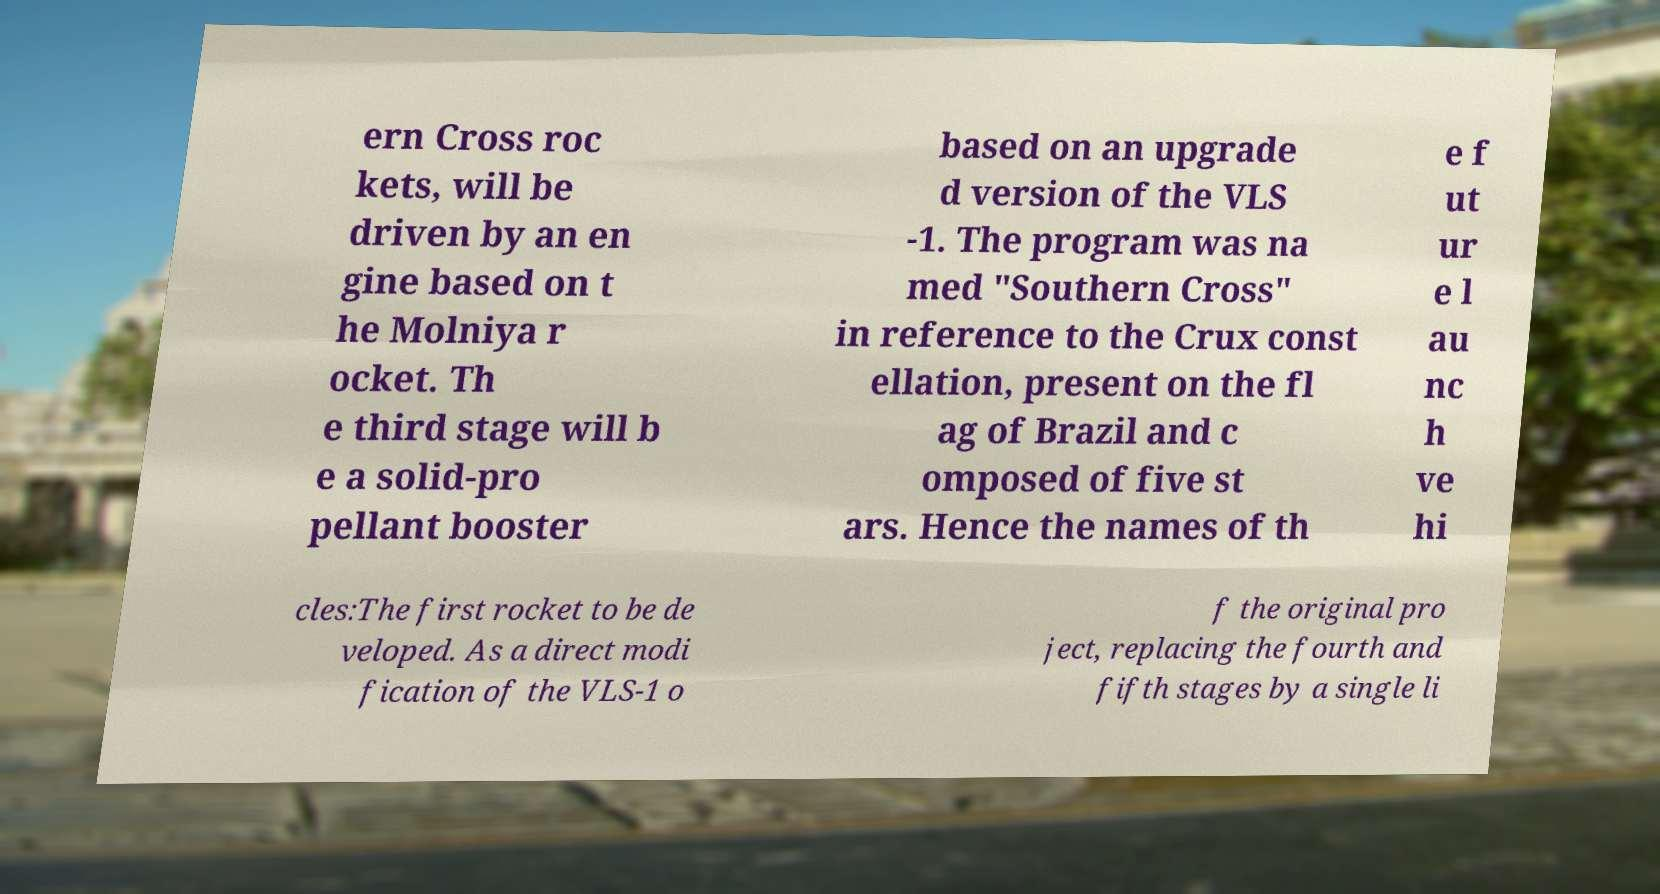Can you read and provide the text displayed in the image?This photo seems to have some interesting text. Can you extract and type it out for me? ern Cross roc kets, will be driven by an en gine based on t he Molniya r ocket. Th e third stage will b e a solid-pro pellant booster based on an upgrade d version of the VLS -1. The program was na med "Southern Cross" in reference to the Crux const ellation, present on the fl ag of Brazil and c omposed of five st ars. Hence the names of th e f ut ur e l au nc h ve hi cles:The first rocket to be de veloped. As a direct modi fication of the VLS-1 o f the original pro ject, replacing the fourth and fifth stages by a single li 